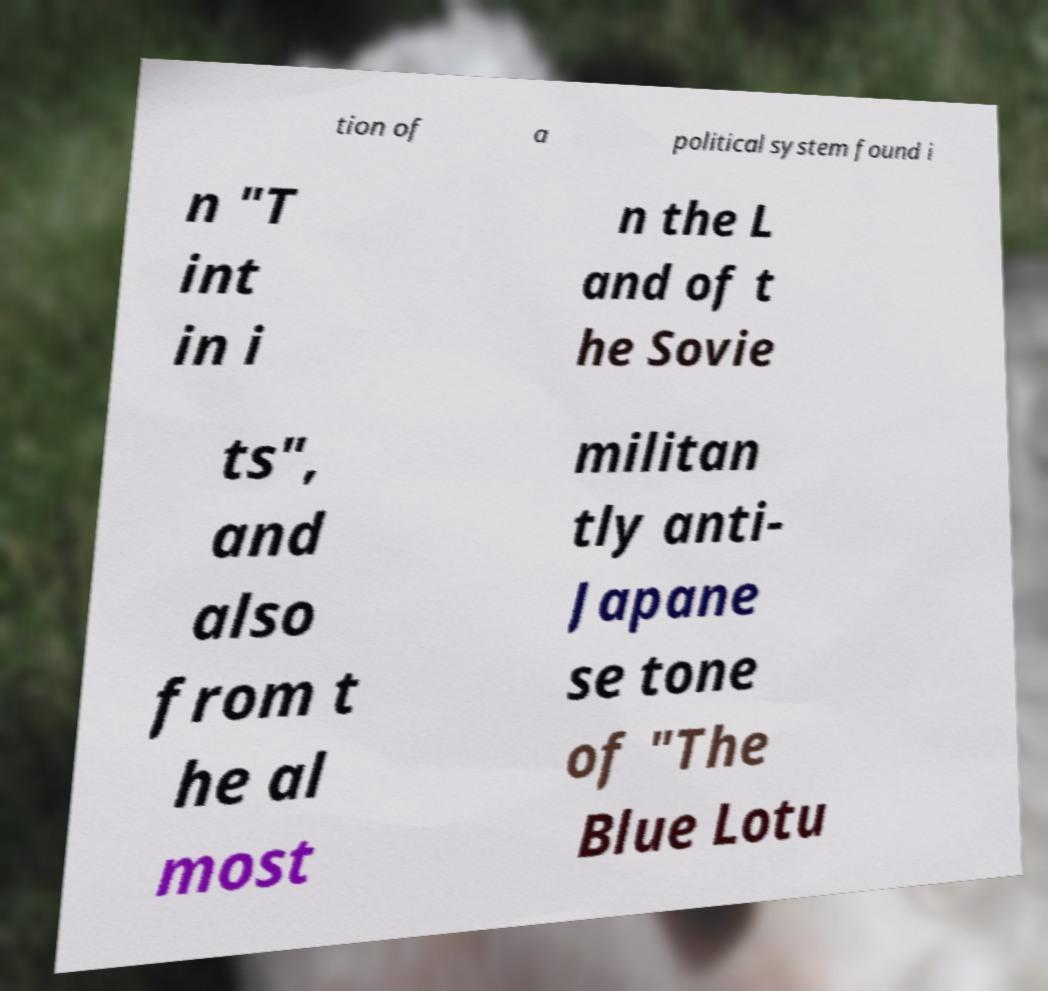There's text embedded in this image that I need extracted. Can you transcribe it verbatim? tion of a political system found i n "T int in i n the L and of t he Sovie ts", and also from t he al most militan tly anti- Japane se tone of "The Blue Lotu 